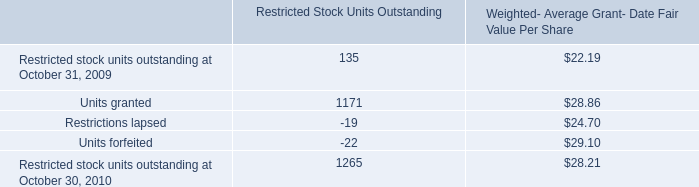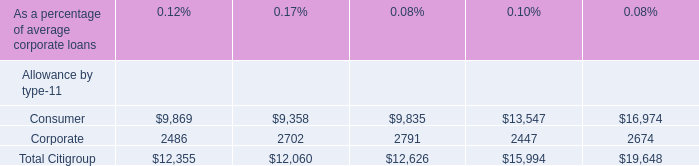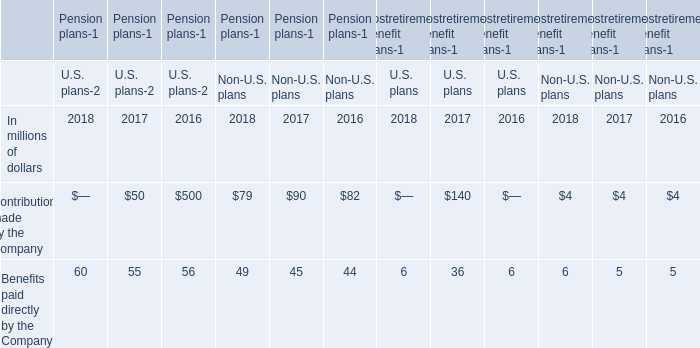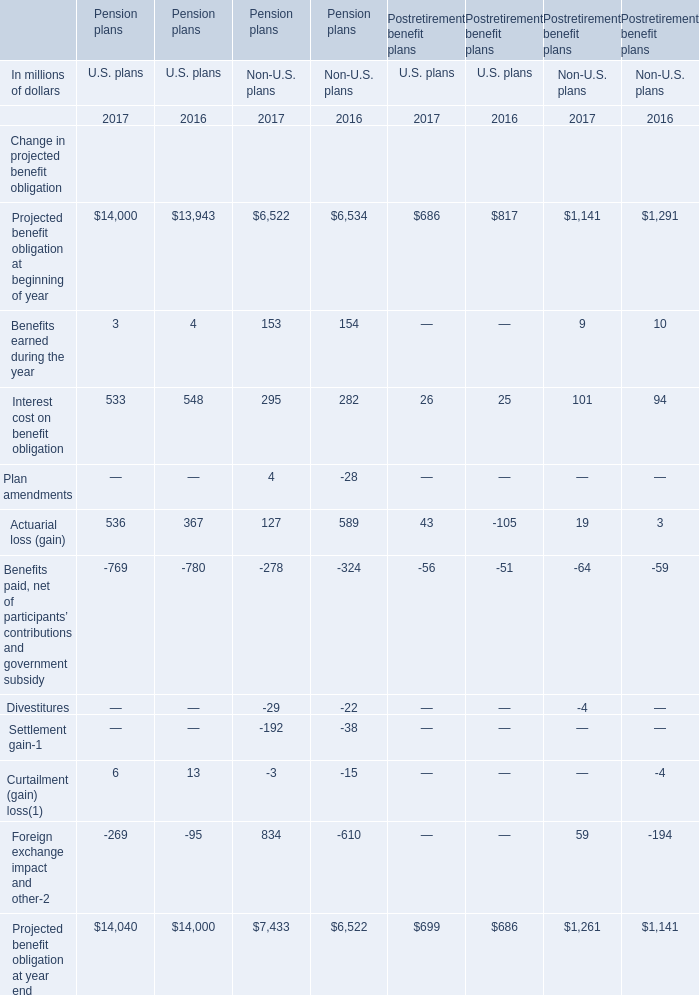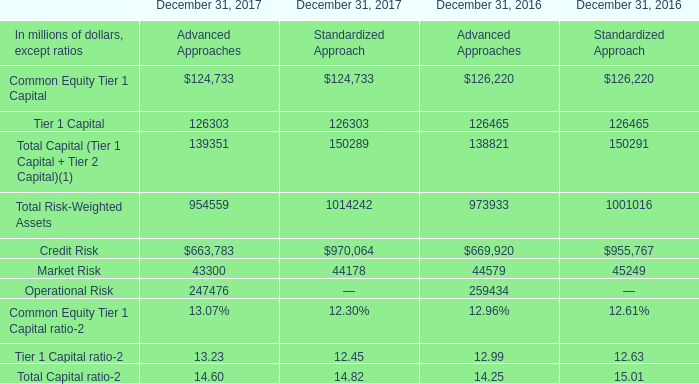If Actuarial loss (gain) of U.S. Pension plans develops with the same growth rate in 2017, what will it reach in 2018? (in million) 
Computations: (536 * (1 + ((536 - 367) / 367)))
Answer: 782.82289. 